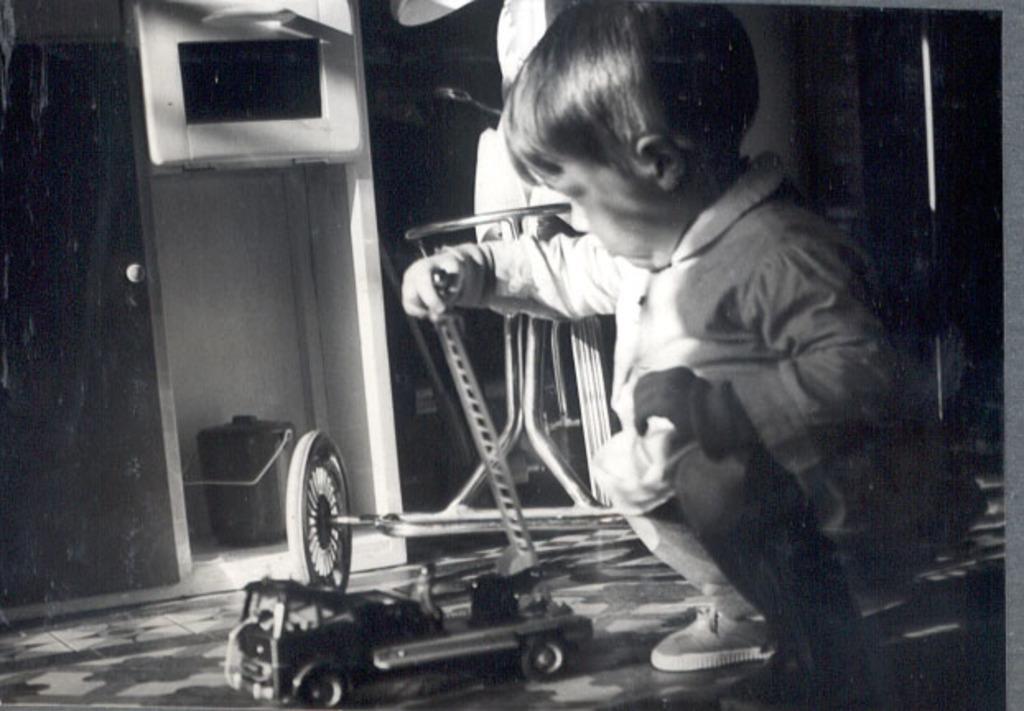How would you summarize this image in a sentence or two? In the center of the image a boy is sitting on his knees and playing with a toy. In the background of the image we can see cupboards, container, wall are there. At the bottom of the image floor is there. 